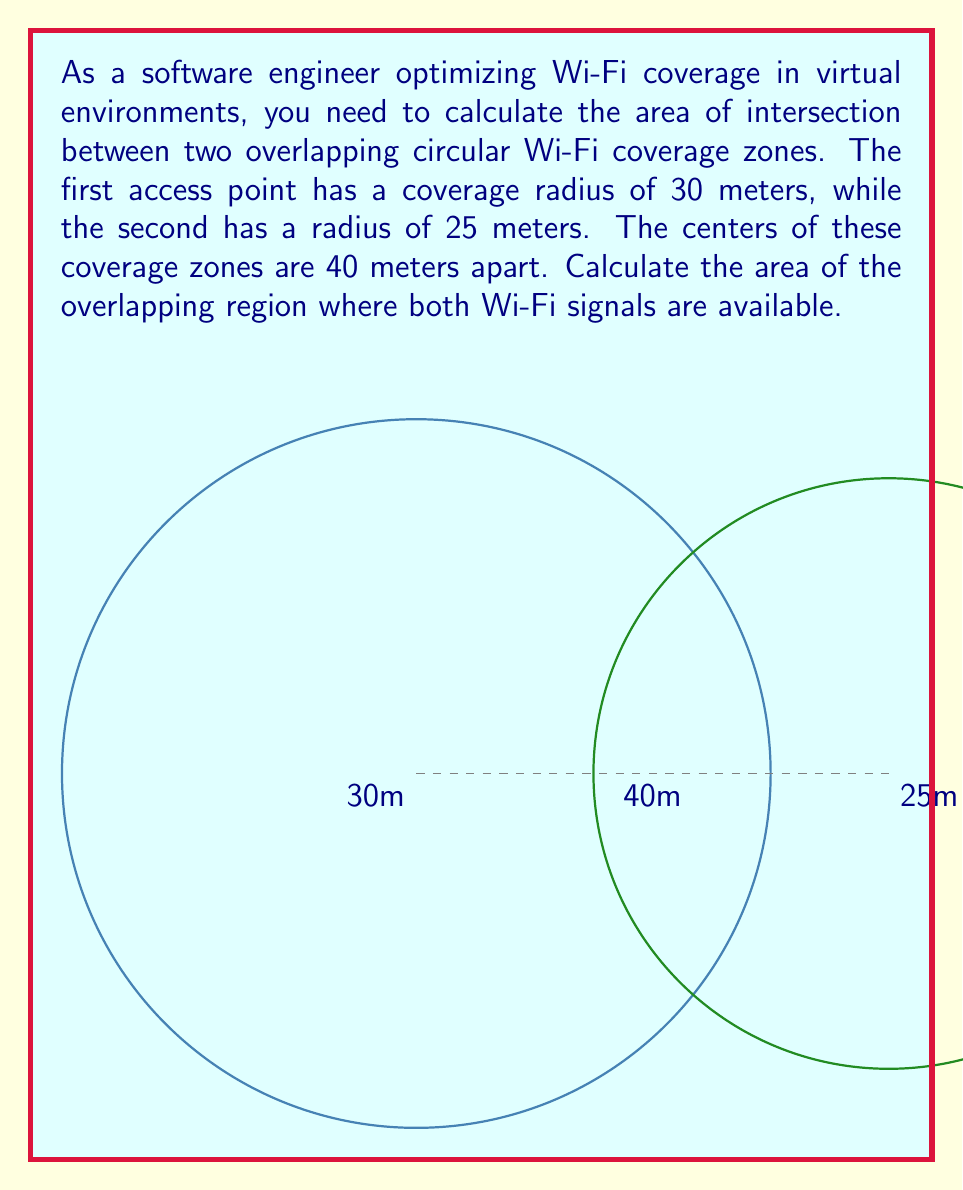Show me your answer to this math problem. To solve this problem, we'll use the formula for the area of intersection between two circles. Let's approach this step-by-step:

1) Let $r_1 = 30$ m (radius of first circle) and $r_2 = 25$ m (radius of second circle).
   The distance between centers, $d = 40$ m.

2) First, we need to calculate the angles $\theta_1$ and $\theta_2$ using the law of cosines:

   $$\cos(\theta_1) = \frac{r_1^2 + d^2 - r_2^2}{2r_1d}$$
   $$\cos(\theta_1) = \frac{30^2 + 40^2 - 25^2}{2 \cdot 30 \cdot 40} = 0.7708$$
   $$\theta_1 = \arccos(0.7708) = 0.6955 \text{ radians}$$

   Similarly,
   $$\cos(\theta_2) = \frac{r_2^2 + d^2 - r_1^2}{2r_2d} = 0.7500$$
   $$\theta_2 = \arccos(0.7500) = 0.7227 \text{ radians}$$

3) The area of intersection is given by:

   $$A = r_1^2 \cdot \theta_1 + r_2^2 \cdot \theta_2 - \frac{1}{2}(r_1^2 \sin(2\theta_1) + r_2^2 \sin(2\theta_2))$$

4) Substituting the values:

   $$A = 30^2 \cdot 0.6955 + 25^2 \cdot 0.7227 - \frac{1}{2}(30^2 \sin(2 \cdot 0.6955) + 25^2 \sin(2 \cdot 0.7227))$$

5) Calculating:

   $$A = 625.95 + 452.94 - \frac{1}{2}(1039.62 + 719.77)$$
   $$A = 1078.89 - 879.70 = 199.19 \text{ m}^2$$

Therefore, the area of the overlapping region is approximately 199.19 square meters.
Answer: 199.19 m² 